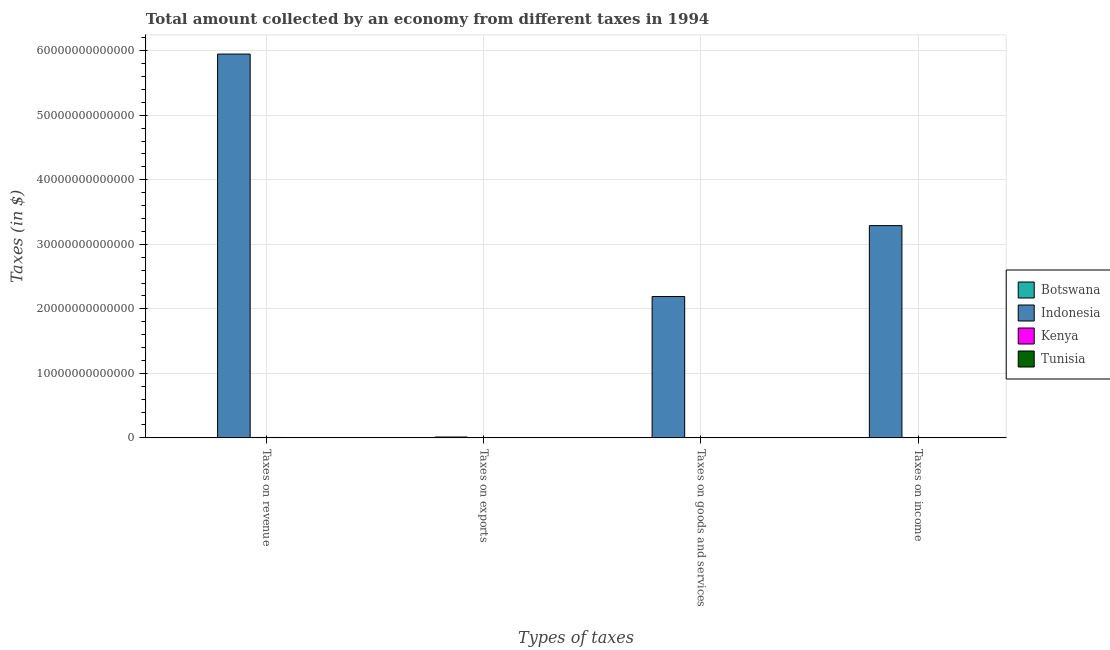How many different coloured bars are there?
Ensure brevity in your answer.  4. How many groups of bars are there?
Make the answer very short. 4. Are the number of bars per tick equal to the number of legend labels?
Give a very brief answer. Yes. Are the number of bars on each tick of the X-axis equal?
Keep it short and to the point. Yes. What is the label of the 2nd group of bars from the left?
Your answer should be very brief. Taxes on exports. What is the amount collected as tax on income in Tunisia?
Keep it short and to the point. 7.34e+08. Across all countries, what is the maximum amount collected as tax on revenue?
Offer a very short reply. 5.95e+13. Across all countries, what is the minimum amount collected as tax on goods?
Your response must be concise. 1.80e+08. In which country was the amount collected as tax on exports maximum?
Offer a very short reply. Indonesia. In which country was the amount collected as tax on goods minimum?
Ensure brevity in your answer.  Botswana. What is the total amount collected as tax on income in the graph?
Make the answer very short. 3.29e+13. What is the difference between the amount collected as tax on revenue in Kenya and that in Tunisia?
Ensure brevity in your answer.  5.66e+1. What is the difference between the amount collected as tax on goods in Tunisia and the amount collected as tax on exports in Kenya?
Your answer should be compact. 9.93e+08. What is the average amount collected as tax on income per country?
Provide a short and direct response. 8.23e+12. What is the difference between the amount collected as tax on revenue and amount collected as tax on goods in Indonesia?
Your response must be concise. 3.76e+13. What is the ratio of the amount collected as tax on exports in Kenya to that in Indonesia?
Your response must be concise. 3.0534351145038166e-5. What is the difference between the highest and the second highest amount collected as tax on income?
Offer a terse response. 3.29e+13. What is the difference between the highest and the lowest amount collected as tax on goods?
Provide a short and direct response. 2.19e+13. Is it the case that in every country, the sum of the amount collected as tax on goods and amount collected as tax on revenue is greater than the sum of amount collected as tax on exports and amount collected as tax on income?
Make the answer very short. No. What does the 1st bar from the right in Taxes on exports represents?
Give a very brief answer. Tunisia. How many bars are there?
Make the answer very short. 16. What is the difference between two consecutive major ticks on the Y-axis?
Offer a terse response. 1.00e+13. Does the graph contain any zero values?
Ensure brevity in your answer.  No. Does the graph contain grids?
Ensure brevity in your answer.  Yes. How are the legend labels stacked?
Offer a terse response. Vertical. What is the title of the graph?
Offer a terse response. Total amount collected by an economy from different taxes in 1994. Does "St. Martin (French part)" appear as one of the legend labels in the graph?
Ensure brevity in your answer.  No. What is the label or title of the X-axis?
Keep it short and to the point. Types of taxes. What is the label or title of the Y-axis?
Ensure brevity in your answer.  Taxes (in $). What is the Taxes (in $) of Botswana in Taxes on revenue?
Offer a very short reply. 2.28e+09. What is the Taxes (in $) of Indonesia in Taxes on revenue?
Ensure brevity in your answer.  5.95e+13. What is the Taxes (in $) of Kenya in Taxes on revenue?
Your response must be concise. 5.98e+1. What is the Taxes (in $) in Tunisia in Taxes on revenue?
Your response must be concise. 3.28e+09. What is the Taxes (in $) of Indonesia in Taxes on exports?
Offer a terse response. 1.31e+11. What is the Taxes (in $) of Kenya in Taxes on exports?
Ensure brevity in your answer.  4.00e+06. What is the Taxes (in $) in Tunisia in Taxes on exports?
Offer a very short reply. 9.70e+06. What is the Taxes (in $) in Botswana in Taxes on goods and services?
Your answer should be compact. 1.80e+08. What is the Taxes (in $) of Indonesia in Taxes on goods and services?
Give a very brief answer. 2.19e+13. What is the Taxes (in $) of Kenya in Taxes on goods and services?
Keep it short and to the point. 3.20e+1. What is the Taxes (in $) of Tunisia in Taxes on goods and services?
Make the answer very short. 9.97e+08. What is the Taxes (in $) of Botswana in Taxes on income?
Keep it short and to the point. 1.38e+09. What is the Taxes (in $) of Indonesia in Taxes on income?
Offer a very short reply. 3.29e+13. What is the Taxes (in $) of Kenya in Taxes on income?
Give a very brief answer. 2.00e+1. What is the Taxes (in $) of Tunisia in Taxes on income?
Keep it short and to the point. 7.34e+08. Across all Types of taxes, what is the maximum Taxes (in $) in Botswana?
Your answer should be very brief. 2.28e+09. Across all Types of taxes, what is the maximum Taxes (in $) of Indonesia?
Give a very brief answer. 5.95e+13. Across all Types of taxes, what is the maximum Taxes (in $) of Kenya?
Offer a very short reply. 5.98e+1. Across all Types of taxes, what is the maximum Taxes (in $) of Tunisia?
Provide a short and direct response. 3.28e+09. Across all Types of taxes, what is the minimum Taxes (in $) of Indonesia?
Offer a very short reply. 1.31e+11. Across all Types of taxes, what is the minimum Taxes (in $) in Tunisia?
Make the answer very short. 9.70e+06. What is the total Taxes (in $) of Botswana in the graph?
Ensure brevity in your answer.  3.84e+09. What is the total Taxes (in $) in Indonesia in the graph?
Offer a very short reply. 1.14e+14. What is the total Taxes (in $) in Kenya in the graph?
Keep it short and to the point. 1.12e+11. What is the total Taxes (in $) of Tunisia in the graph?
Provide a short and direct response. 5.02e+09. What is the difference between the Taxes (in $) in Botswana in Taxes on revenue and that in Taxes on exports?
Ensure brevity in your answer.  2.28e+09. What is the difference between the Taxes (in $) of Indonesia in Taxes on revenue and that in Taxes on exports?
Offer a terse response. 5.94e+13. What is the difference between the Taxes (in $) of Kenya in Taxes on revenue and that in Taxes on exports?
Your answer should be very brief. 5.98e+1. What is the difference between the Taxes (in $) in Tunisia in Taxes on revenue and that in Taxes on exports?
Offer a very short reply. 3.27e+09. What is the difference between the Taxes (in $) in Botswana in Taxes on revenue and that in Taxes on goods and services?
Your answer should be very brief. 2.10e+09. What is the difference between the Taxes (in $) in Indonesia in Taxes on revenue and that in Taxes on goods and services?
Keep it short and to the point. 3.76e+13. What is the difference between the Taxes (in $) of Kenya in Taxes on revenue and that in Taxes on goods and services?
Give a very brief answer. 2.78e+1. What is the difference between the Taxes (in $) of Tunisia in Taxes on revenue and that in Taxes on goods and services?
Provide a short and direct response. 2.29e+09. What is the difference between the Taxes (in $) in Botswana in Taxes on revenue and that in Taxes on income?
Offer a terse response. 8.96e+08. What is the difference between the Taxes (in $) of Indonesia in Taxes on revenue and that in Taxes on income?
Ensure brevity in your answer.  2.66e+13. What is the difference between the Taxes (in $) of Kenya in Taxes on revenue and that in Taxes on income?
Ensure brevity in your answer.  3.99e+1. What is the difference between the Taxes (in $) of Tunisia in Taxes on revenue and that in Taxes on income?
Your answer should be compact. 2.55e+09. What is the difference between the Taxes (in $) of Botswana in Taxes on exports and that in Taxes on goods and services?
Your response must be concise. -1.80e+08. What is the difference between the Taxes (in $) in Indonesia in Taxes on exports and that in Taxes on goods and services?
Provide a short and direct response. -2.18e+13. What is the difference between the Taxes (in $) in Kenya in Taxes on exports and that in Taxes on goods and services?
Offer a terse response. -3.20e+1. What is the difference between the Taxes (in $) of Tunisia in Taxes on exports and that in Taxes on goods and services?
Your answer should be compact. -9.87e+08. What is the difference between the Taxes (in $) of Botswana in Taxes on exports and that in Taxes on income?
Make the answer very short. -1.38e+09. What is the difference between the Taxes (in $) in Indonesia in Taxes on exports and that in Taxes on income?
Your response must be concise. -3.28e+13. What is the difference between the Taxes (in $) of Kenya in Taxes on exports and that in Taxes on income?
Make the answer very short. -2.00e+1. What is the difference between the Taxes (in $) in Tunisia in Taxes on exports and that in Taxes on income?
Offer a very short reply. -7.24e+08. What is the difference between the Taxes (in $) of Botswana in Taxes on goods and services and that in Taxes on income?
Keep it short and to the point. -1.20e+09. What is the difference between the Taxes (in $) of Indonesia in Taxes on goods and services and that in Taxes on income?
Provide a succinct answer. -1.10e+13. What is the difference between the Taxes (in $) of Kenya in Taxes on goods and services and that in Taxes on income?
Provide a succinct answer. 1.20e+1. What is the difference between the Taxes (in $) in Tunisia in Taxes on goods and services and that in Taxes on income?
Provide a succinct answer. 2.63e+08. What is the difference between the Taxes (in $) of Botswana in Taxes on revenue and the Taxes (in $) of Indonesia in Taxes on exports?
Make the answer very short. -1.29e+11. What is the difference between the Taxes (in $) of Botswana in Taxes on revenue and the Taxes (in $) of Kenya in Taxes on exports?
Give a very brief answer. 2.27e+09. What is the difference between the Taxes (in $) in Botswana in Taxes on revenue and the Taxes (in $) in Tunisia in Taxes on exports?
Keep it short and to the point. 2.27e+09. What is the difference between the Taxes (in $) in Indonesia in Taxes on revenue and the Taxes (in $) in Kenya in Taxes on exports?
Keep it short and to the point. 5.95e+13. What is the difference between the Taxes (in $) in Indonesia in Taxes on revenue and the Taxes (in $) in Tunisia in Taxes on exports?
Your answer should be compact. 5.95e+13. What is the difference between the Taxes (in $) in Kenya in Taxes on revenue and the Taxes (in $) in Tunisia in Taxes on exports?
Keep it short and to the point. 5.98e+1. What is the difference between the Taxes (in $) of Botswana in Taxes on revenue and the Taxes (in $) of Indonesia in Taxes on goods and services?
Keep it short and to the point. -2.19e+13. What is the difference between the Taxes (in $) in Botswana in Taxes on revenue and the Taxes (in $) in Kenya in Taxes on goods and services?
Your answer should be very brief. -2.97e+1. What is the difference between the Taxes (in $) of Botswana in Taxes on revenue and the Taxes (in $) of Tunisia in Taxes on goods and services?
Keep it short and to the point. 1.28e+09. What is the difference between the Taxes (in $) of Indonesia in Taxes on revenue and the Taxes (in $) of Kenya in Taxes on goods and services?
Ensure brevity in your answer.  5.94e+13. What is the difference between the Taxes (in $) in Indonesia in Taxes on revenue and the Taxes (in $) in Tunisia in Taxes on goods and services?
Give a very brief answer. 5.95e+13. What is the difference between the Taxes (in $) in Kenya in Taxes on revenue and the Taxes (in $) in Tunisia in Taxes on goods and services?
Ensure brevity in your answer.  5.88e+1. What is the difference between the Taxes (in $) in Botswana in Taxes on revenue and the Taxes (in $) in Indonesia in Taxes on income?
Provide a succinct answer. -3.29e+13. What is the difference between the Taxes (in $) of Botswana in Taxes on revenue and the Taxes (in $) of Kenya in Taxes on income?
Provide a succinct answer. -1.77e+1. What is the difference between the Taxes (in $) in Botswana in Taxes on revenue and the Taxes (in $) in Tunisia in Taxes on income?
Your answer should be compact. 1.54e+09. What is the difference between the Taxes (in $) of Indonesia in Taxes on revenue and the Taxes (in $) of Kenya in Taxes on income?
Offer a terse response. 5.95e+13. What is the difference between the Taxes (in $) of Indonesia in Taxes on revenue and the Taxes (in $) of Tunisia in Taxes on income?
Provide a succinct answer. 5.95e+13. What is the difference between the Taxes (in $) in Kenya in Taxes on revenue and the Taxes (in $) in Tunisia in Taxes on income?
Your answer should be compact. 5.91e+1. What is the difference between the Taxes (in $) of Botswana in Taxes on exports and the Taxes (in $) of Indonesia in Taxes on goods and services?
Ensure brevity in your answer.  -2.19e+13. What is the difference between the Taxes (in $) of Botswana in Taxes on exports and the Taxes (in $) of Kenya in Taxes on goods and services?
Keep it short and to the point. -3.20e+1. What is the difference between the Taxes (in $) in Botswana in Taxes on exports and the Taxes (in $) in Tunisia in Taxes on goods and services?
Provide a succinct answer. -9.96e+08. What is the difference between the Taxes (in $) in Indonesia in Taxes on exports and the Taxes (in $) in Kenya in Taxes on goods and services?
Keep it short and to the point. 9.90e+1. What is the difference between the Taxes (in $) in Indonesia in Taxes on exports and the Taxes (in $) in Tunisia in Taxes on goods and services?
Your answer should be very brief. 1.30e+11. What is the difference between the Taxes (in $) in Kenya in Taxes on exports and the Taxes (in $) in Tunisia in Taxes on goods and services?
Offer a terse response. -9.93e+08. What is the difference between the Taxes (in $) in Botswana in Taxes on exports and the Taxes (in $) in Indonesia in Taxes on income?
Your answer should be compact. -3.29e+13. What is the difference between the Taxes (in $) in Botswana in Taxes on exports and the Taxes (in $) in Kenya in Taxes on income?
Provide a short and direct response. -2.00e+1. What is the difference between the Taxes (in $) of Botswana in Taxes on exports and the Taxes (in $) of Tunisia in Taxes on income?
Your response must be concise. -7.33e+08. What is the difference between the Taxes (in $) of Indonesia in Taxes on exports and the Taxes (in $) of Kenya in Taxes on income?
Offer a very short reply. 1.11e+11. What is the difference between the Taxes (in $) in Indonesia in Taxes on exports and the Taxes (in $) in Tunisia in Taxes on income?
Ensure brevity in your answer.  1.30e+11. What is the difference between the Taxes (in $) in Kenya in Taxes on exports and the Taxes (in $) in Tunisia in Taxes on income?
Your answer should be compact. -7.30e+08. What is the difference between the Taxes (in $) in Botswana in Taxes on goods and services and the Taxes (in $) in Indonesia in Taxes on income?
Offer a very short reply. -3.29e+13. What is the difference between the Taxes (in $) in Botswana in Taxes on goods and services and the Taxes (in $) in Kenya in Taxes on income?
Your response must be concise. -1.98e+1. What is the difference between the Taxes (in $) in Botswana in Taxes on goods and services and the Taxes (in $) in Tunisia in Taxes on income?
Your response must be concise. -5.54e+08. What is the difference between the Taxes (in $) in Indonesia in Taxes on goods and services and the Taxes (in $) in Kenya in Taxes on income?
Ensure brevity in your answer.  2.19e+13. What is the difference between the Taxes (in $) of Indonesia in Taxes on goods and services and the Taxes (in $) of Tunisia in Taxes on income?
Your answer should be very brief. 2.19e+13. What is the difference between the Taxes (in $) of Kenya in Taxes on goods and services and the Taxes (in $) of Tunisia in Taxes on income?
Your response must be concise. 3.13e+1. What is the average Taxes (in $) in Botswana per Types of taxes?
Offer a terse response. 9.60e+08. What is the average Taxes (in $) of Indonesia per Types of taxes?
Offer a terse response. 2.86e+13. What is the average Taxes (in $) in Kenya per Types of taxes?
Make the answer very short. 2.80e+1. What is the average Taxes (in $) of Tunisia per Types of taxes?
Provide a succinct answer. 1.26e+09. What is the difference between the Taxes (in $) of Botswana and Taxes (in $) of Indonesia in Taxes on revenue?
Make the answer very short. -5.95e+13. What is the difference between the Taxes (in $) in Botswana and Taxes (in $) in Kenya in Taxes on revenue?
Ensure brevity in your answer.  -5.76e+1. What is the difference between the Taxes (in $) in Botswana and Taxes (in $) in Tunisia in Taxes on revenue?
Make the answer very short. -1.01e+09. What is the difference between the Taxes (in $) in Indonesia and Taxes (in $) in Kenya in Taxes on revenue?
Keep it short and to the point. 5.94e+13. What is the difference between the Taxes (in $) of Indonesia and Taxes (in $) of Tunisia in Taxes on revenue?
Your answer should be very brief. 5.95e+13. What is the difference between the Taxes (in $) in Kenya and Taxes (in $) in Tunisia in Taxes on revenue?
Offer a terse response. 5.66e+1. What is the difference between the Taxes (in $) of Botswana and Taxes (in $) of Indonesia in Taxes on exports?
Offer a terse response. -1.31e+11. What is the difference between the Taxes (in $) of Botswana and Taxes (in $) of Kenya in Taxes on exports?
Make the answer very short. -3.60e+06. What is the difference between the Taxes (in $) of Botswana and Taxes (in $) of Tunisia in Taxes on exports?
Your response must be concise. -9.30e+06. What is the difference between the Taxes (in $) in Indonesia and Taxes (in $) in Kenya in Taxes on exports?
Your answer should be very brief. 1.31e+11. What is the difference between the Taxes (in $) of Indonesia and Taxes (in $) of Tunisia in Taxes on exports?
Your answer should be compact. 1.31e+11. What is the difference between the Taxes (in $) of Kenya and Taxes (in $) of Tunisia in Taxes on exports?
Keep it short and to the point. -5.70e+06. What is the difference between the Taxes (in $) in Botswana and Taxes (in $) in Indonesia in Taxes on goods and services?
Provide a succinct answer. -2.19e+13. What is the difference between the Taxes (in $) of Botswana and Taxes (in $) of Kenya in Taxes on goods and services?
Provide a short and direct response. -3.18e+1. What is the difference between the Taxes (in $) of Botswana and Taxes (in $) of Tunisia in Taxes on goods and services?
Your answer should be very brief. -8.17e+08. What is the difference between the Taxes (in $) of Indonesia and Taxes (in $) of Kenya in Taxes on goods and services?
Provide a short and direct response. 2.19e+13. What is the difference between the Taxes (in $) in Indonesia and Taxes (in $) in Tunisia in Taxes on goods and services?
Offer a terse response. 2.19e+13. What is the difference between the Taxes (in $) in Kenya and Taxes (in $) in Tunisia in Taxes on goods and services?
Your answer should be very brief. 3.10e+1. What is the difference between the Taxes (in $) in Botswana and Taxes (in $) in Indonesia in Taxes on income?
Give a very brief answer. -3.29e+13. What is the difference between the Taxes (in $) of Botswana and Taxes (in $) of Kenya in Taxes on income?
Your answer should be compact. -1.86e+1. What is the difference between the Taxes (in $) of Botswana and Taxes (in $) of Tunisia in Taxes on income?
Your answer should be very brief. 6.47e+08. What is the difference between the Taxes (in $) in Indonesia and Taxes (in $) in Kenya in Taxes on income?
Keep it short and to the point. 3.29e+13. What is the difference between the Taxes (in $) in Indonesia and Taxes (in $) in Tunisia in Taxes on income?
Give a very brief answer. 3.29e+13. What is the difference between the Taxes (in $) in Kenya and Taxes (in $) in Tunisia in Taxes on income?
Offer a very short reply. 1.92e+1. What is the ratio of the Taxes (in $) in Botswana in Taxes on revenue to that in Taxes on exports?
Keep it short and to the point. 5693.5. What is the ratio of the Taxes (in $) in Indonesia in Taxes on revenue to that in Taxes on exports?
Keep it short and to the point. 454.05. What is the ratio of the Taxes (in $) in Kenya in Taxes on revenue to that in Taxes on exports?
Provide a succinct answer. 1.50e+04. What is the ratio of the Taxes (in $) in Tunisia in Taxes on revenue to that in Taxes on exports?
Provide a succinct answer. 338.52. What is the ratio of the Taxes (in $) in Botswana in Taxes on revenue to that in Taxes on goods and services?
Offer a very short reply. 12.65. What is the ratio of the Taxes (in $) in Indonesia in Taxes on revenue to that in Taxes on goods and services?
Offer a terse response. 2.72. What is the ratio of the Taxes (in $) of Kenya in Taxes on revenue to that in Taxes on goods and services?
Provide a short and direct response. 1.87. What is the ratio of the Taxes (in $) in Tunisia in Taxes on revenue to that in Taxes on goods and services?
Offer a very short reply. 3.29. What is the ratio of the Taxes (in $) in Botswana in Taxes on revenue to that in Taxes on income?
Give a very brief answer. 1.65. What is the ratio of the Taxes (in $) of Indonesia in Taxes on revenue to that in Taxes on income?
Give a very brief answer. 1.81. What is the ratio of the Taxes (in $) of Kenya in Taxes on revenue to that in Taxes on income?
Give a very brief answer. 3. What is the ratio of the Taxes (in $) of Tunisia in Taxes on revenue to that in Taxes on income?
Your answer should be very brief. 4.47. What is the ratio of the Taxes (in $) of Botswana in Taxes on exports to that in Taxes on goods and services?
Make the answer very short. 0. What is the ratio of the Taxes (in $) in Indonesia in Taxes on exports to that in Taxes on goods and services?
Keep it short and to the point. 0.01. What is the ratio of the Taxes (in $) of Kenya in Taxes on exports to that in Taxes on goods and services?
Provide a short and direct response. 0. What is the ratio of the Taxes (in $) in Tunisia in Taxes on exports to that in Taxes on goods and services?
Your response must be concise. 0.01. What is the ratio of the Taxes (in $) of Indonesia in Taxes on exports to that in Taxes on income?
Ensure brevity in your answer.  0. What is the ratio of the Taxes (in $) in Tunisia in Taxes on exports to that in Taxes on income?
Your response must be concise. 0.01. What is the ratio of the Taxes (in $) in Botswana in Taxes on goods and services to that in Taxes on income?
Make the answer very short. 0.13. What is the ratio of the Taxes (in $) of Indonesia in Taxes on goods and services to that in Taxes on income?
Keep it short and to the point. 0.67. What is the ratio of the Taxes (in $) in Kenya in Taxes on goods and services to that in Taxes on income?
Your answer should be very brief. 1.6. What is the ratio of the Taxes (in $) in Tunisia in Taxes on goods and services to that in Taxes on income?
Your answer should be compact. 1.36. What is the difference between the highest and the second highest Taxes (in $) in Botswana?
Your answer should be compact. 8.96e+08. What is the difference between the highest and the second highest Taxes (in $) of Indonesia?
Offer a very short reply. 2.66e+13. What is the difference between the highest and the second highest Taxes (in $) of Kenya?
Your response must be concise. 2.78e+1. What is the difference between the highest and the second highest Taxes (in $) in Tunisia?
Make the answer very short. 2.29e+09. What is the difference between the highest and the lowest Taxes (in $) in Botswana?
Keep it short and to the point. 2.28e+09. What is the difference between the highest and the lowest Taxes (in $) of Indonesia?
Give a very brief answer. 5.94e+13. What is the difference between the highest and the lowest Taxes (in $) in Kenya?
Keep it short and to the point. 5.98e+1. What is the difference between the highest and the lowest Taxes (in $) of Tunisia?
Ensure brevity in your answer.  3.27e+09. 